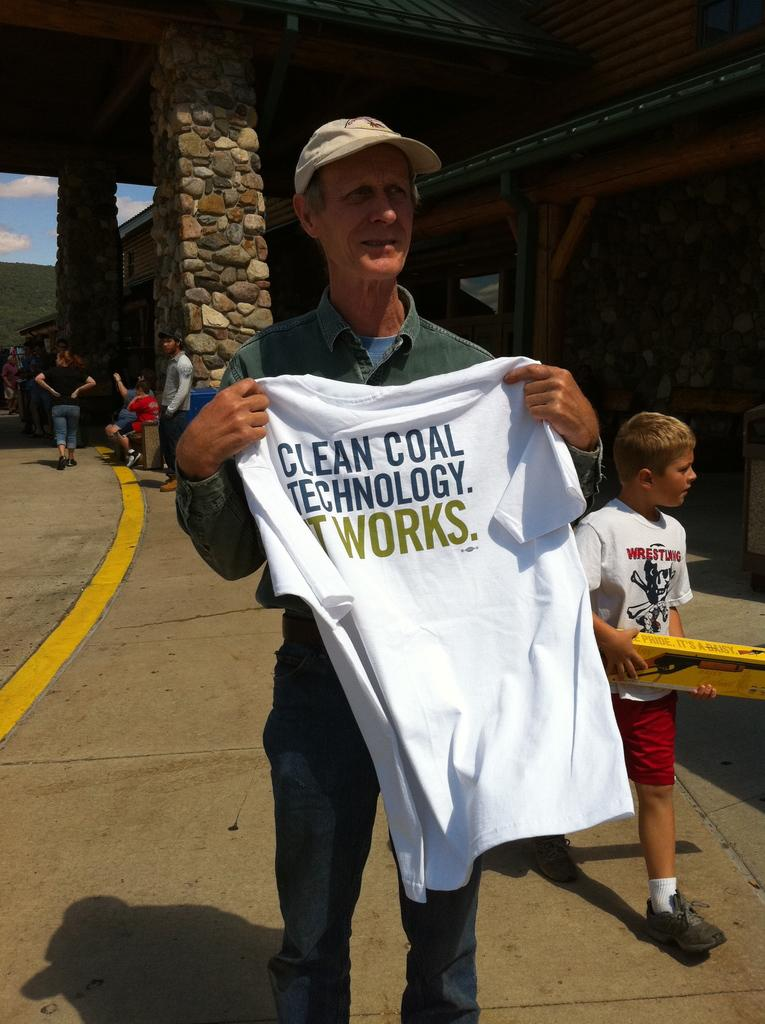<image>
Describe the image concisely. A man holds up a t-shirt advertising for clean coal technology. 